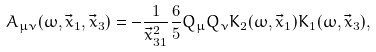<formula> <loc_0><loc_0><loc_500><loc_500>A _ { \mu \nu } ( \omega , \vec { x } _ { 1 } , \vec { x } _ { 3 } ) = - \frac { 1 } { \vec { x } _ { 3 1 } ^ { 2 } } \frac { 6 } { 5 } Q _ { \mu } Q _ { \nu } K _ { 2 } ( \omega , \vec { x } _ { 1 } ) K _ { 1 } ( \omega , \vec { x } _ { 3 } ) ,</formula> 